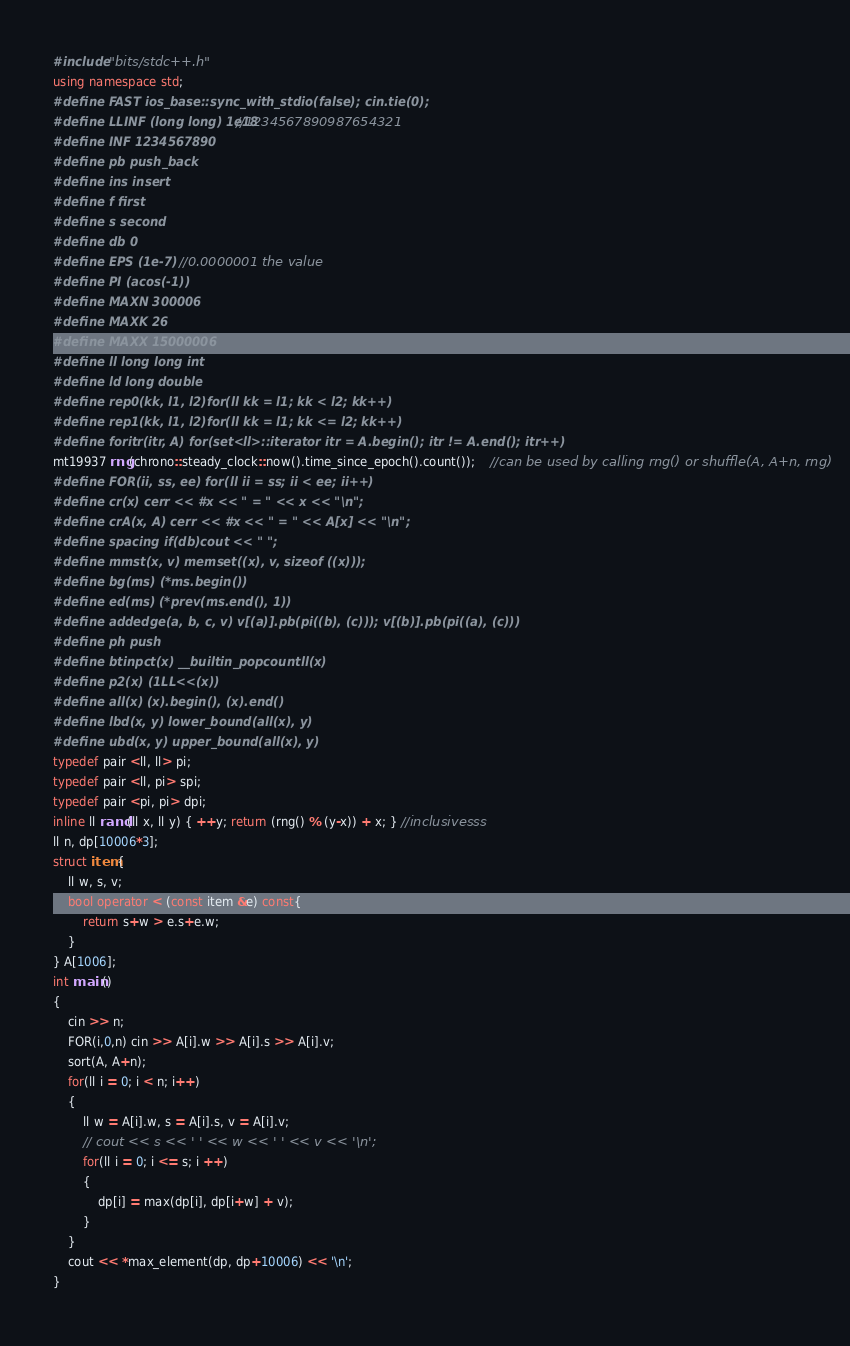<code> <loc_0><loc_0><loc_500><loc_500><_C++_>#include "bits/stdc++.h"
using namespace std;
#define FAST ios_base::sync_with_stdio(false); cin.tie(0);
#define LLINF (long long) 1e18//1234567890987654321
#define INF 1234567890
#define pb push_back
#define ins insert
#define f first
#define s second	
#define db 0
#define EPS (1e-7)    //0.0000001 the value
#define PI (acos(-1))
#define MAXN 300006
#define MAXK 26
#define MAXX 15000006
#define ll long long int
#define ld long double
#define rep0(kk, l1, l2)for(ll kk = l1; kk < l2; kk++)
#define rep1(kk, l1, l2)for(ll kk = l1; kk <= l2; kk++)
#define foritr(itr, A) for(set<ll>::iterator itr = A.begin(); itr != A.end(); itr++)
mt19937 rng(chrono::steady_clock::now().time_since_epoch().count());    //can be used by calling rng() or shuffle(A, A+n, rng)
#define FOR(ii, ss, ee) for(ll ii = ss; ii < ee; ii++)
#define cr(x) cerr << #x << " = " << x << "\n";
#define crA(x, A) cerr << #x << " = " << A[x] << "\n";
#define spacing if(db)cout << " ";
#define mmst(x, v) memset((x), v, sizeof ((x)));
#define bg(ms) (*ms.begin())
#define ed(ms) (*prev(ms.end(), 1))
#define addedge(a, b, c, v) v[(a)].pb(pi((b), (c))); v[(b)].pb(pi((a), (c)))
#define ph push
#define btinpct(x) __builtin_popcountll(x)
#define p2(x) (1LL<<(x))
#define all(x) (x).begin(), (x).end()
#define lbd(x, y) lower_bound(all(x), y)
#define ubd(x, y) upper_bound(all(x), y)
typedef pair <ll, ll> pi;
typedef pair <ll, pi> spi;
typedef pair <pi, pi> dpi;
inline ll rand(ll x, ll y) { ++y; return (rng() % (y-x)) + x; } //inclusivesss
ll n, dp[10006*3];
struct item{
	ll w, s, v;
	bool operator < (const item &e) const{
		return s+w > e.s+e.w;
	}
} A[1006];
int main()
{
	cin >> n;
	FOR(i,0,n) cin >> A[i].w >> A[i].s >> A[i].v;
	sort(A, A+n);
	for(ll i = 0; i < n; i++)
	{
		ll w = A[i].w, s = A[i].s, v = A[i].v;
		// cout << s << ' ' << w << ' ' << v << '\n';
		for(ll i = 0; i <= s; i ++)
		{
			dp[i] = max(dp[i], dp[i+w] + v);
		}
	}
	cout << *max_element(dp, dp+10006) << '\n';
}
</code> 